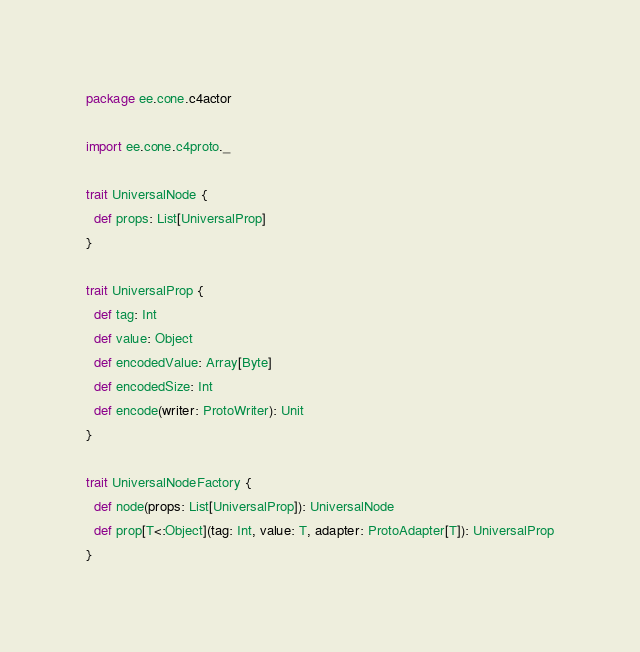<code> <loc_0><loc_0><loc_500><loc_500><_Scala_>package ee.cone.c4actor

import ee.cone.c4proto._

trait UniversalNode {
  def props: List[UniversalProp]
}

trait UniversalProp {
  def tag: Int
  def value: Object
  def encodedValue: Array[Byte]
  def encodedSize: Int
  def encode(writer: ProtoWriter): Unit
}

trait UniversalNodeFactory {
  def node(props: List[UniversalProp]): UniversalNode
  def prop[T<:Object](tag: Int, value: T, adapter: ProtoAdapter[T]): UniversalProp
}</code> 